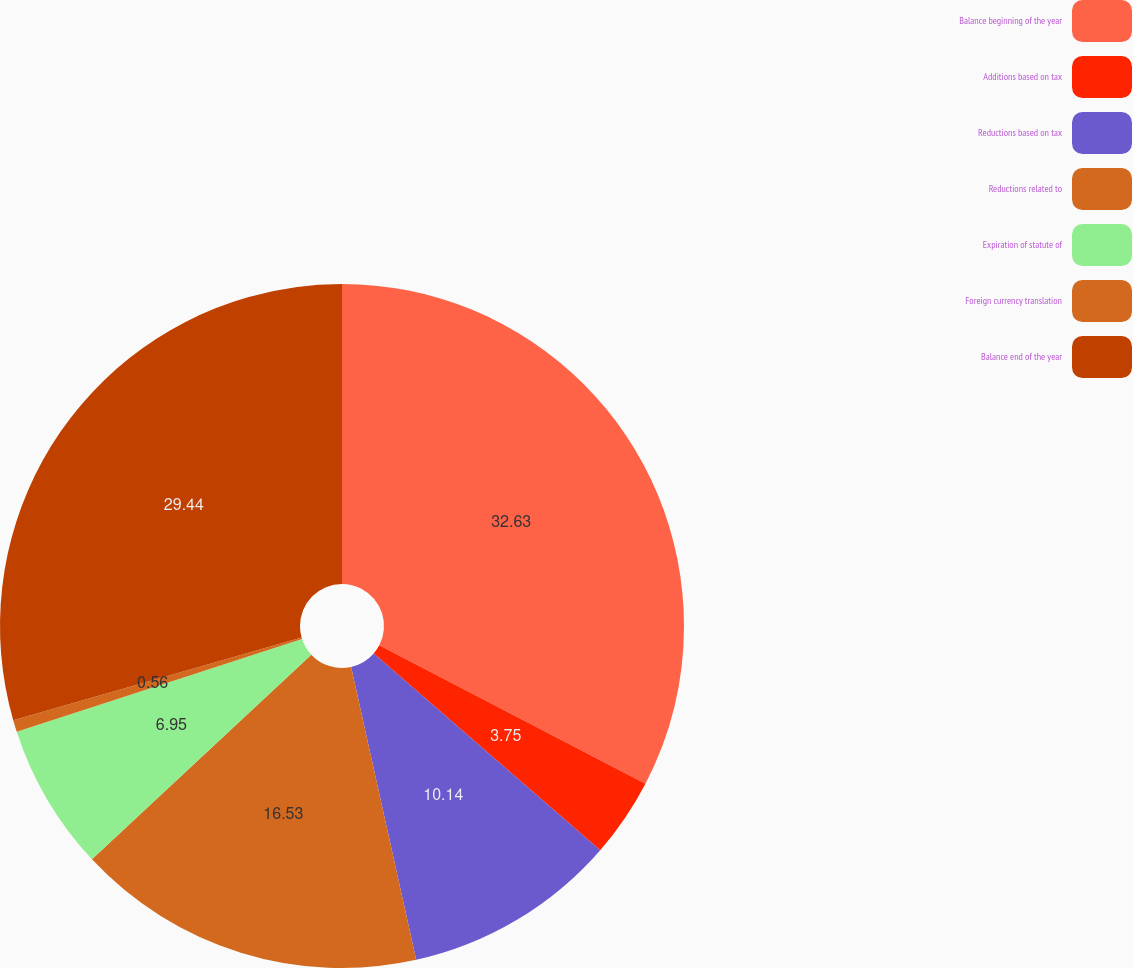Convert chart to OTSL. <chart><loc_0><loc_0><loc_500><loc_500><pie_chart><fcel>Balance beginning of the year<fcel>Additions based on tax<fcel>Reductions based on tax<fcel>Reductions related to<fcel>Expiration of statute of<fcel>Foreign currency translation<fcel>Balance end of the year<nl><fcel>32.63%<fcel>3.75%<fcel>10.14%<fcel>16.53%<fcel>6.95%<fcel>0.56%<fcel>29.44%<nl></chart> 